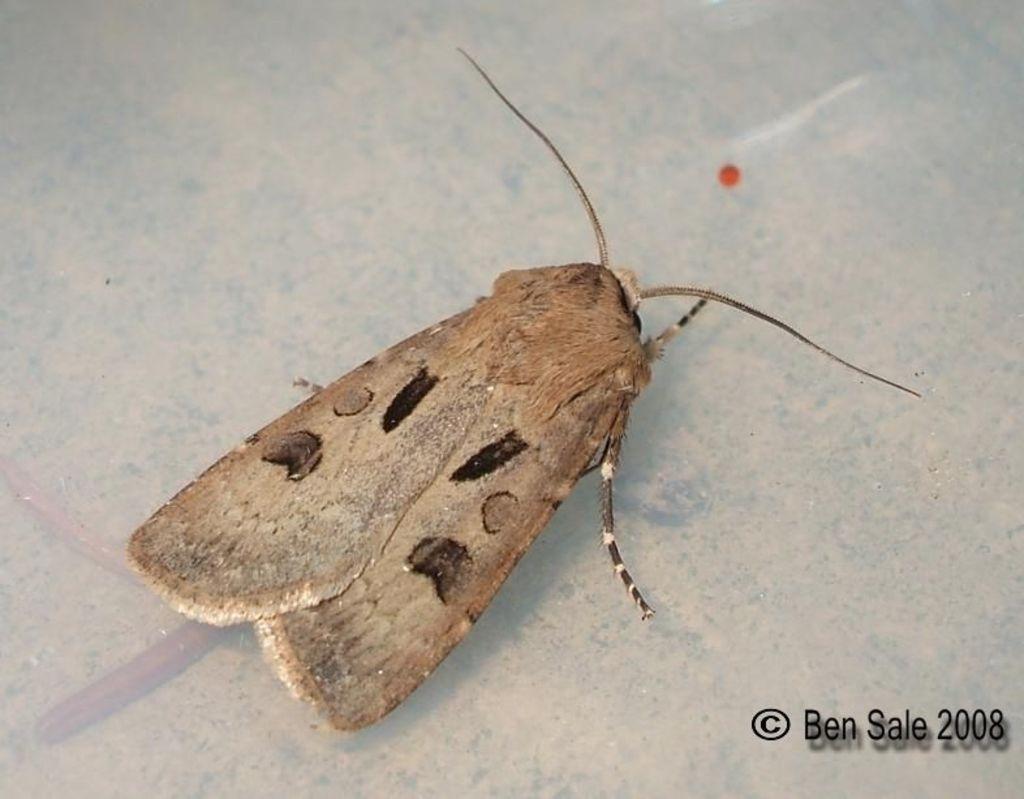Could you give a brief overview of what you see in this image? In this picture I can see insect on the surface. 